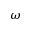Convert formula to latex. <formula><loc_0><loc_0><loc_500><loc_500>\omega</formula> 